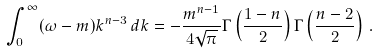Convert formula to latex. <formula><loc_0><loc_0><loc_500><loc_500>\int _ { 0 } ^ { \infty } ( \omega - m ) k ^ { n - 3 } \, d k = - \frac { m ^ { n - 1 } } { 4 \sqrt { \pi } } \Gamma \left ( \frac { 1 - n } { 2 } \right ) \Gamma \left ( \frac { n - 2 } { 2 } \right ) \, .</formula> 